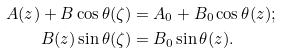<formula> <loc_0><loc_0><loc_500><loc_500>A ( z ) + B \cos \theta ( \zeta ) & = A _ { 0 } + B _ { 0 } \cos \theta ( z ) ; \\ B ( z ) \sin \theta ( \zeta ) & = B _ { 0 } \sin \theta ( z ) .</formula> 